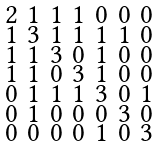<formula> <loc_0><loc_0><loc_500><loc_500>\begin{smallmatrix} 2 & 1 & 1 & 1 & 0 & 0 & 0 \\ 1 & 3 & 1 & 1 & 1 & 1 & 0 \\ 1 & 1 & 3 & 0 & 1 & 0 & 0 \\ 1 & 1 & 0 & 3 & 1 & 0 & 0 \\ 0 & 1 & 1 & 1 & 3 & 0 & 1 \\ 0 & 1 & 0 & 0 & 0 & 3 & 0 \\ 0 & 0 & 0 & 0 & 1 & 0 & 3 \end{smallmatrix}</formula> 